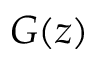<formula> <loc_0><loc_0><loc_500><loc_500>G ( z )</formula> 